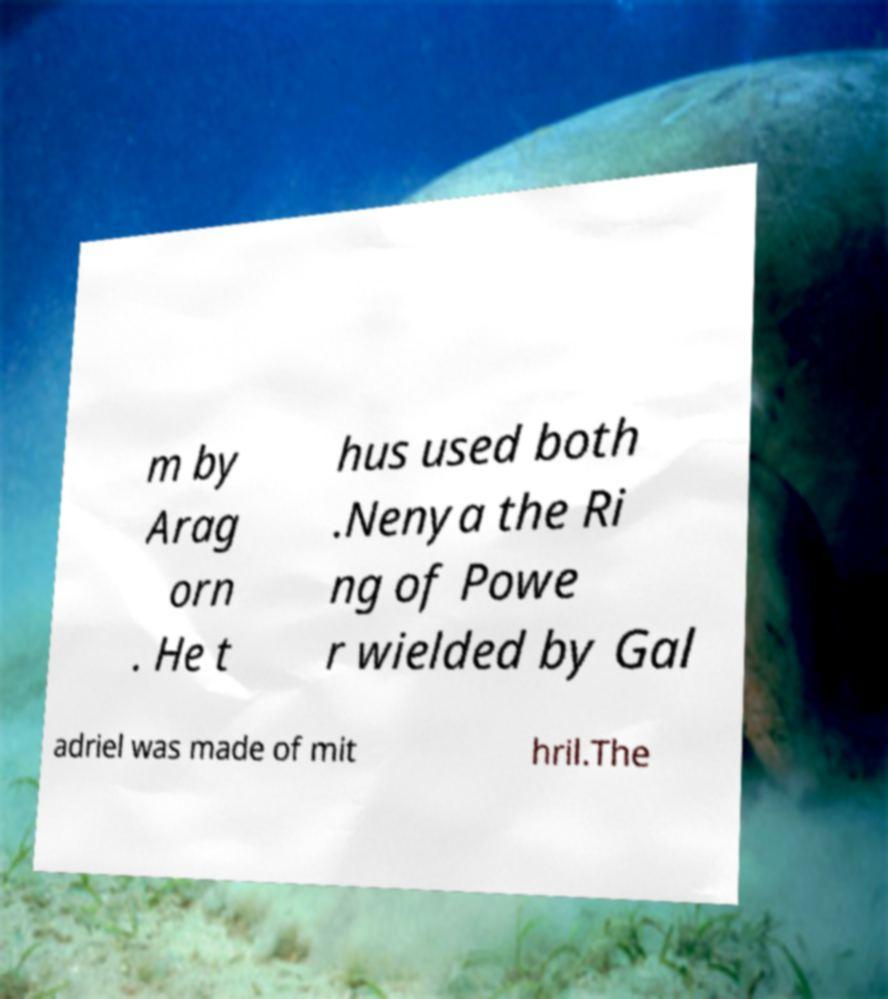There's text embedded in this image that I need extracted. Can you transcribe it verbatim? m by Arag orn . He t hus used both .Nenya the Ri ng of Powe r wielded by Gal adriel was made of mit hril.The 